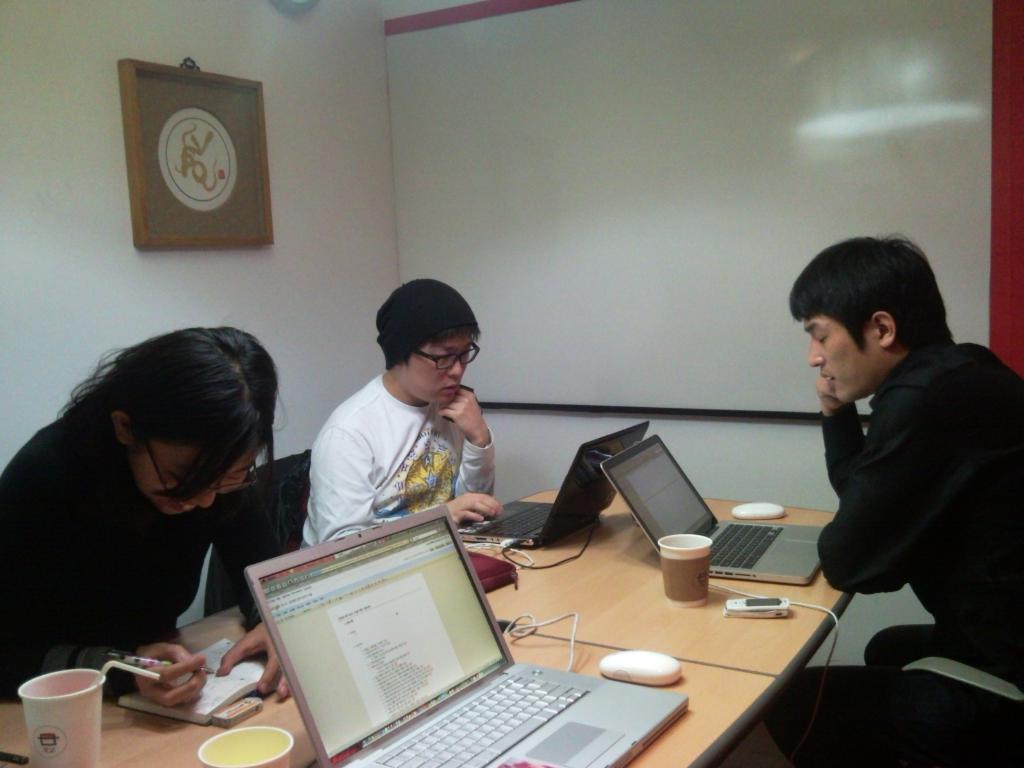Can you describe this image briefly? Here we can see that a person is sitting on the chair, and in front there is the laptop and some glasses and some other objects on it, and in front there is a man sitting and working on the laptop, and beside a woman is siting, and she is smiling, and writing in the book, and at back there is the wall, and photo frame on it. 